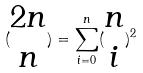Convert formula to latex. <formula><loc_0><loc_0><loc_500><loc_500>( \begin{matrix} 2 n \\ n \end{matrix} ) = \sum _ { i = 0 } ^ { n } ( \begin{matrix} n \\ i \end{matrix} ) ^ { 2 }</formula> 